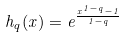Convert formula to latex. <formula><loc_0><loc_0><loc_500><loc_500>h _ { q } ( x ) = e ^ { \frac { { x } ^ { 1 - q } - 1 } { 1 - q } }</formula> 